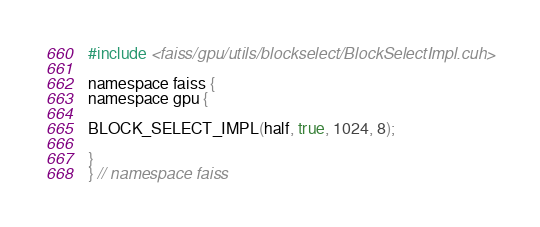Convert code to text. <code><loc_0><loc_0><loc_500><loc_500><_Cuda_>
#include <faiss/gpu/utils/blockselect/BlockSelectImpl.cuh>

namespace faiss {
namespace gpu {

BLOCK_SELECT_IMPL(half, true, 1024, 8);

}
} // namespace faiss
</code> 